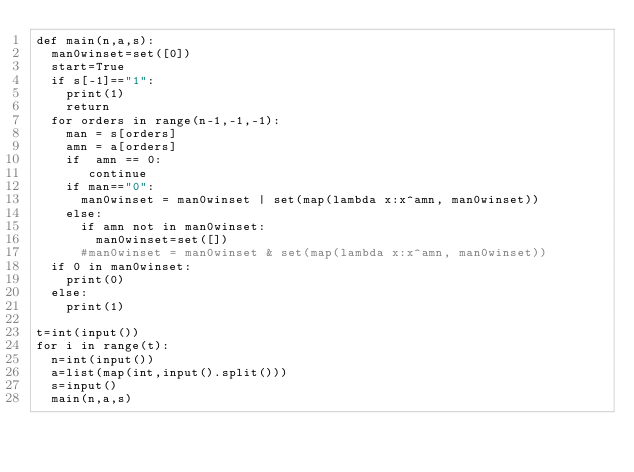Convert code to text. <code><loc_0><loc_0><loc_500><loc_500><_Python_>def main(n,a,s):
  man0winset=set([0])
  start=True
  if s[-1]=="1":
    print(1)
    return
  for orders in range(n-1,-1,-1):
    man = s[orders]
    amn = a[orders]
    if  amn == 0:
       continue
    if man=="0":
      man0winset = man0winset | set(map(lambda x:x^amn, man0winset))
    else:
      if amn not in man0winset:
        man0winset=set([])
      #man0winset = man0winset & set(map(lambda x:x^amn, man0winset))
  if 0 in man0winset:
    print(0)
  else:
    print(1)
    
t=int(input())
for i in range(t):
  n=int(input())
  a=list(map(int,input().split()))
  s=input()
  main(n,a,s)</code> 